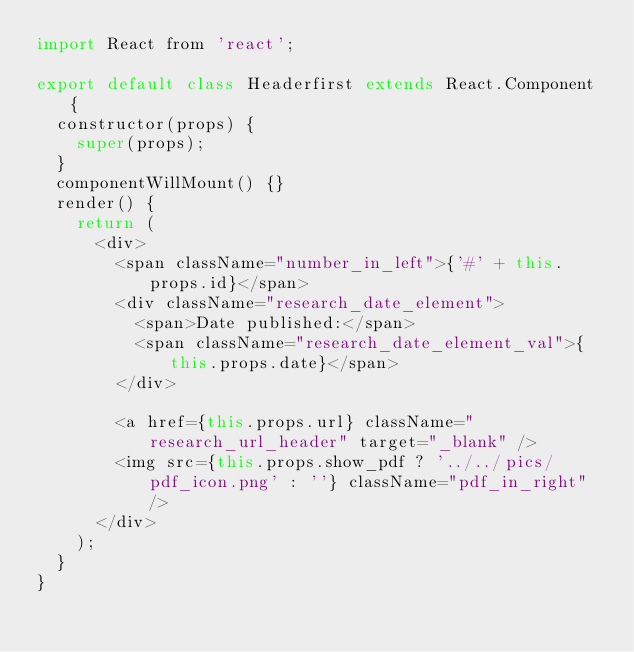<code> <loc_0><loc_0><loc_500><loc_500><_JavaScript_>import React from 'react';

export default class Headerfirst extends React.Component {
  constructor(props) {
    super(props);
  }
  componentWillMount() {}
  render() {
    return (
      <div>
        <span className="number_in_left">{'#' + this.props.id}</span>
        <div className="research_date_element">
          <span>Date published:</span>
          <span className="research_date_element_val">{this.props.date}</span>
        </div>

        <a href={this.props.url} className="research_url_header" target="_blank" />
        <img src={this.props.show_pdf ? '../../pics/pdf_icon.png' : ''} className="pdf_in_right" />
      </div>
    );
  }
}
</code> 